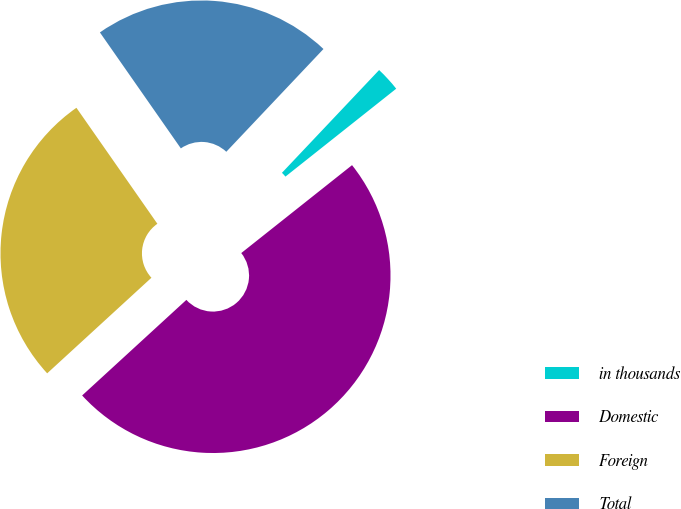Convert chart to OTSL. <chart><loc_0><loc_0><loc_500><loc_500><pie_chart><fcel>in thousands<fcel>Domestic<fcel>Foreign<fcel>Total<nl><fcel>2.27%<fcel>48.86%<fcel>27.11%<fcel>21.75%<nl></chart> 